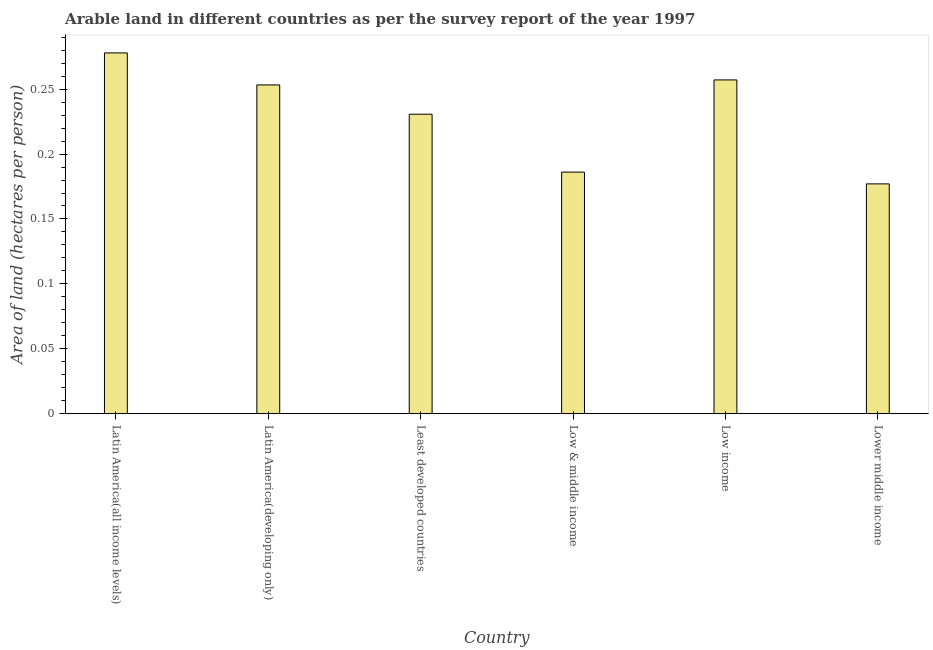Does the graph contain grids?
Give a very brief answer. No. What is the title of the graph?
Provide a succinct answer. Arable land in different countries as per the survey report of the year 1997. What is the label or title of the Y-axis?
Provide a short and direct response. Area of land (hectares per person). What is the area of arable land in Lower middle income?
Make the answer very short. 0.18. Across all countries, what is the maximum area of arable land?
Offer a terse response. 0.28. Across all countries, what is the minimum area of arable land?
Provide a succinct answer. 0.18. In which country was the area of arable land maximum?
Offer a terse response. Latin America(all income levels). In which country was the area of arable land minimum?
Keep it short and to the point. Lower middle income. What is the sum of the area of arable land?
Offer a terse response. 1.38. What is the difference between the area of arable land in Latin America(all income levels) and Least developed countries?
Your answer should be very brief. 0.05. What is the average area of arable land per country?
Your answer should be very brief. 0.23. What is the median area of arable land?
Provide a short and direct response. 0.24. Is the area of arable land in Latin America(developing only) less than that in Lower middle income?
Your answer should be compact. No. What is the difference between the highest and the second highest area of arable land?
Your response must be concise. 0.02. Is the sum of the area of arable land in Least developed countries and Low income greater than the maximum area of arable land across all countries?
Provide a succinct answer. Yes. In how many countries, is the area of arable land greater than the average area of arable land taken over all countries?
Your response must be concise. 4. Are all the bars in the graph horizontal?
Make the answer very short. No. What is the difference between two consecutive major ticks on the Y-axis?
Your answer should be very brief. 0.05. What is the Area of land (hectares per person) of Latin America(all income levels)?
Your answer should be compact. 0.28. What is the Area of land (hectares per person) in Latin America(developing only)?
Your answer should be compact. 0.25. What is the Area of land (hectares per person) of Least developed countries?
Your answer should be compact. 0.23. What is the Area of land (hectares per person) of Low & middle income?
Provide a short and direct response. 0.19. What is the Area of land (hectares per person) of Low income?
Offer a very short reply. 0.26. What is the Area of land (hectares per person) of Lower middle income?
Provide a short and direct response. 0.18. What is the difference between the Area of land (hectares per person) in Latin America(all income levels) and Latin America(developing only)?
Offer a very short reply. 0.02. What is the difference between the Area of land (hectares per person) in Latin America(all income levels) and Least developed countries?
Give a very brief answer. 0.05. What is the difference between the Area of land (hectares per person) in Latin America(all income levels) and Low & middle income?
Offer a very short reply. 0.09. What is the difference between the Area of land (hectares per person) in Latin America(all income levels) and Low income?
Give a very brief answer. 0.02. What is the difference between the Area of land (hectares per person) in Latin America(all income levels) and Lower middle income?
Provide a succinct answer. 0.1. What is the difference between the Area of land (hectares per person) in Latin America(developing only) and Least developed countries?
Provide a short and direct response. 0.02. What is the difference between the Area of land (hectares per person) in Latin America(developing only) and Low & middle income?
Offer a terse response. 0.07. What is the difference between the Area of land (hectares per person) in Latin America(developing only) and Low income?
Keep it short and to the point. -0. What is the difference between the Area of land (hectares per person) in Latin America(developing only) and Lower middle income?
Give a very brief answer. 0.08. What is the difference between the Area of land (hectares per person) in Least developed countries and Low & middle income?
Your answer should be compact. 0.04. What is the difference between the Area of land (hectares per person) in Least developed countries and Low income?
Provide a succinct answer. -0.03. What is the difference between the Area of land (hectares per person) in Least developed countries and Lower middle income?
Give a very brief answer. 0.05. What is the difference between the Area of land (hectares per person) in Low & middle income and Low income?
Offer a terse response. -0.07. What is the difference between the Area of land (hectares per person) in Low & middle income and Lower middle income?
Your answer should be very brief. 0.01. What is the difference between the Area of land (hectares per person) in Low income and Lower middle income?
Provide a succinct answer. 0.08. What is the ratio of the Area of land (hectares per person) in Latin America(all income levels) to that in Latin America(developing only)?
Keep it short and to the point. 1.1. What is the ratio of the Area of land (hectares per person) in Latin America(all income levels) to that in Least developed countries?
Give a very brief answer. 1.21. What is the ratio of the Area of land (hectares per person) in Latin America(all income levels) to that in Low & middle income?
Give a very brief answer. 1.49. What is the ratio of the Area of land (hectares per person) in Latin America(all income levels) to that in Low income?
Your answer should be very brief. 1.08. What is the ratio of the Area of land (hectares per person) in Latin America(all income levels) to that in Lower middle income?
Provide a short and direct response. 1.57. What is the ratio of the Area of land (hectares per person) in Latin America(developing only) to that in Least developed countries?
Give a very brief answer. 1.1. What is the ratio of the Area of land (hectares per person) in Latin America(developing only) to that in Low & middle income?
Give a very brief answer. 1.36. What is the ratio of the Area of land (hectares per person) in Latin America(developing only) to that in Lower middle income?
Your answer should be very brief. 1.43. What is the ratio of the Area of land (hectares per person) in Least developed countries to that in Low & middle income?
Your answer should be compact. 1.24. What is the ratio of the Area of land (hectares per person) in Least developed countries to that in Low income?
Make the answer very short. 0.9. What is the ratio of the Area of land (hectares per person) in Least developed countries to that in Lower middle income?
Your response must be concise. 1.3. What is the ratio of the Area of land (hectares per person) in Low & middle income to that in Low income?
Give a very brief answer. 0.72. What is the ratio of the Area of land (hectares per person) in Low & middle income to that in Lower middle income?
Your response must be concise. 1.05. What is the ratio of the Area of land (hectares per person) in Low income to that in Lower middle income?
Make the answer very short. 1.45. 